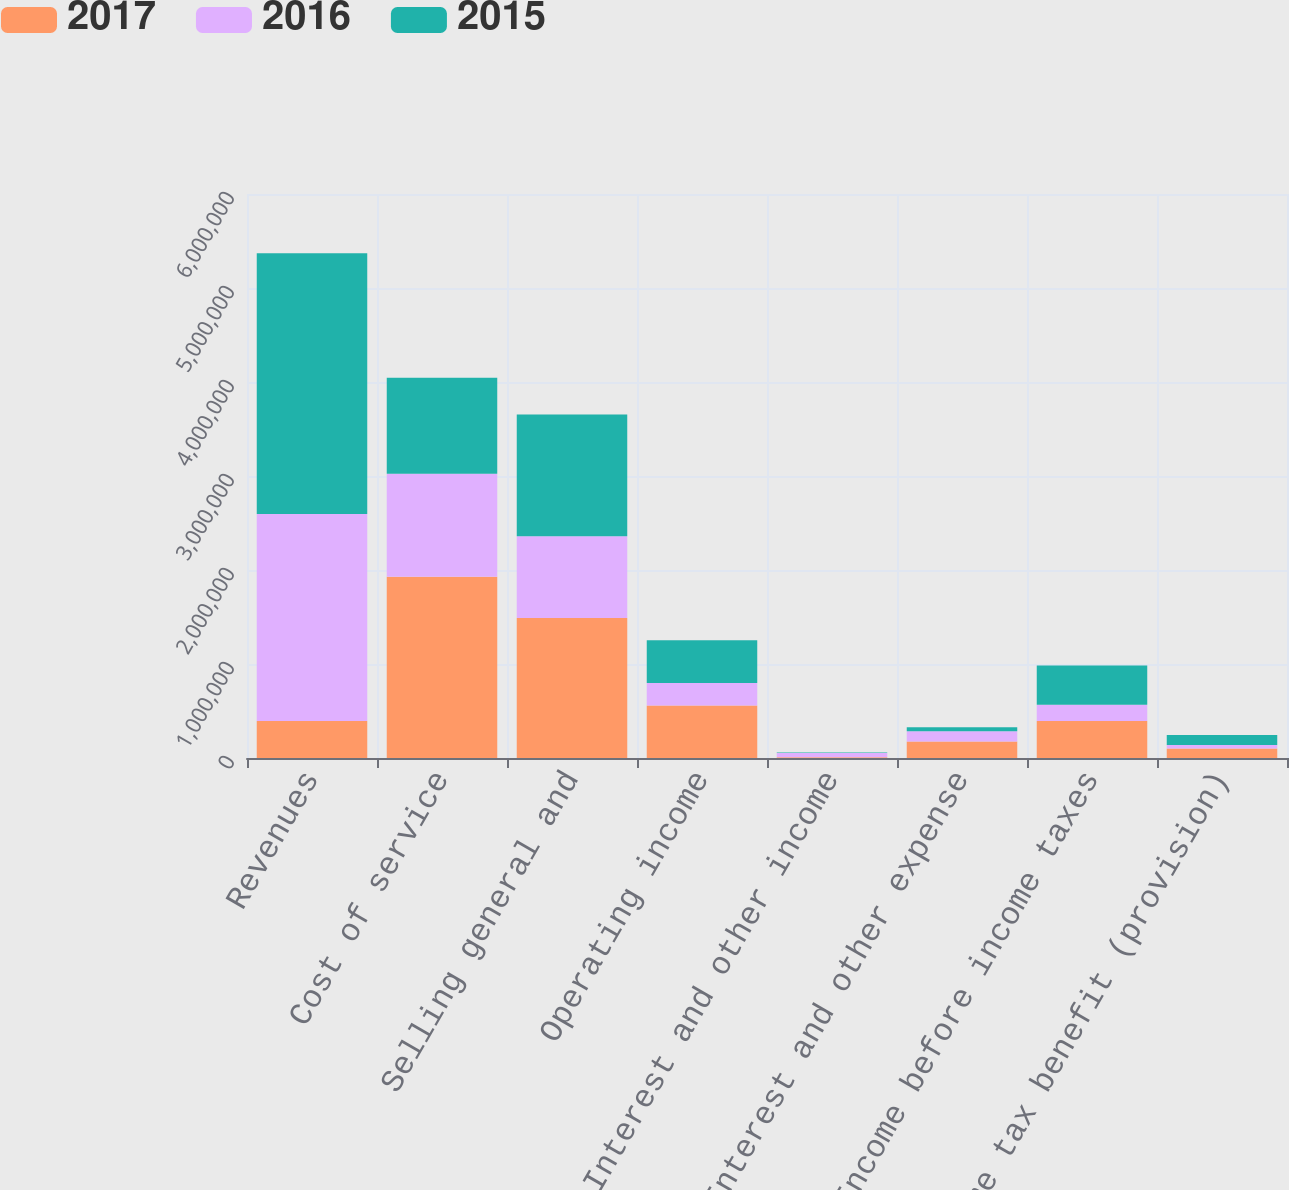<chart> <loc_0><loc_0><loc_500><loc_500><stacked_bar_chart><ecel><fcel>Revenues<fcel>Cost of service<fcel>Selling general and<fcel>Operating income<fcel>Interest and other income<fcel>Interest and other expense<fcel>Income before income taxes<fcel>Income tax benefit (provision)<nl><fcel>2017<fcel>392683<fcel>1.92804e+06<fcel>1.48826e+06<fcel>558868<fcel>8662<fcel>174847<fcel>392683<fcel>101387<nl><fcel>2016<fcel>2.2029e+06<fcel>1.09459e+06<fcel>870352<fcel>237951<fcel>44382<fcel>108989<fcel>173344<fcel>35661<nl><fcel>2015<fcel>2.77372e+06<fcel>1.02211e+06<fcel>1.29501e+06<fcel>456597<fcel>4949<fcel>44436<fcel>417110<fcel>107995<nl></chart> 